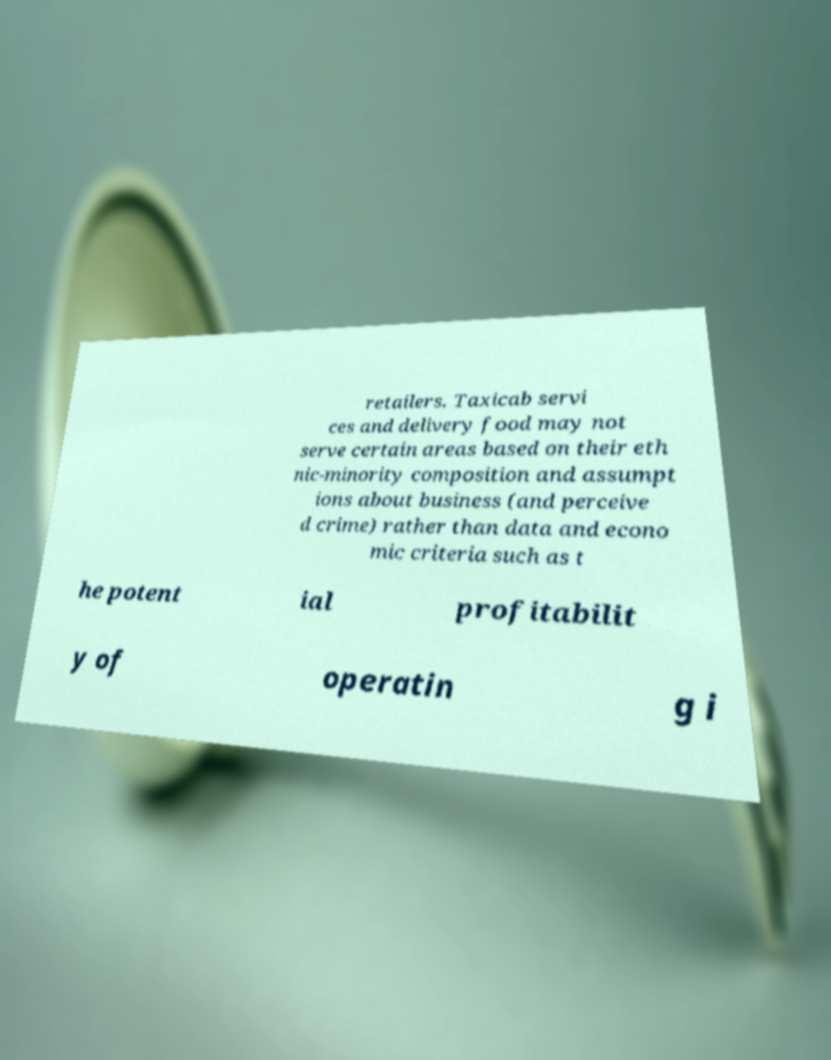What messages or text are displayed in this image? I need them in a readable, typed format. retailers. Taxicab servi ces and delivery food may not serve certain areas based on their eth nic-minority composition and assumpt ions about business (and perceive d crime) rather than data and econo mic criteria such as t he potent ial profitabilit y of operatin g i 